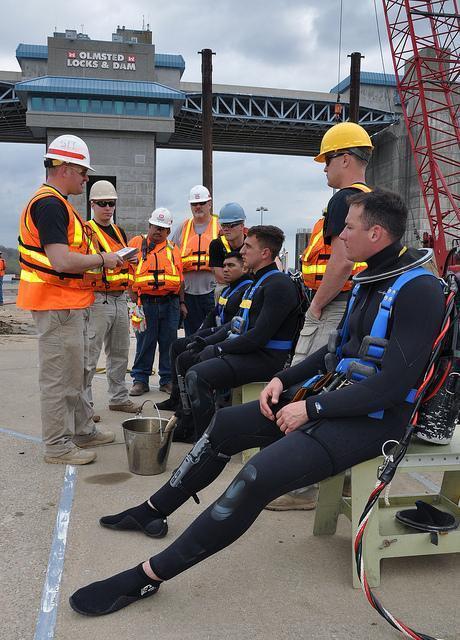How many people are there?
Give a very brief answer. 8. How many spots does the giraffe on the left have exposed on its neck?
Give a very brief answer. 0. 